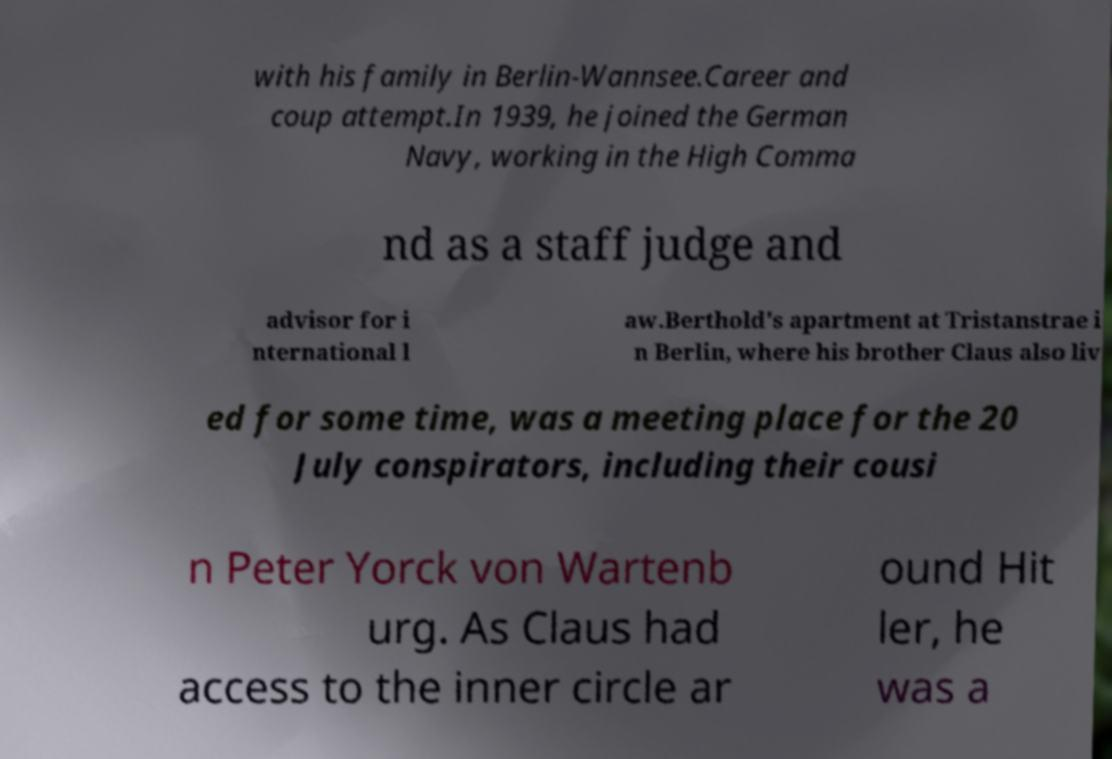Can you read and provide the text displayed in the image?This photo seems to have some interesting text. Can you extract and type it out for me? with his family in Berlin-Wannsee.Career and coup attempt.In 1939, he joined the German Navy, working in the High Comma nd as a staff judge and advisor for i nternational l aw.Berthold's apartment at Tristanstrae i n Berlin, where his brother Claus also liv ed for some time, was a meeting place for the 20 July conspirators, including their cousi n Peter Yorck von Wartenb urg. As Claus had access to the inner circle ar ound Hit ler, he was a 